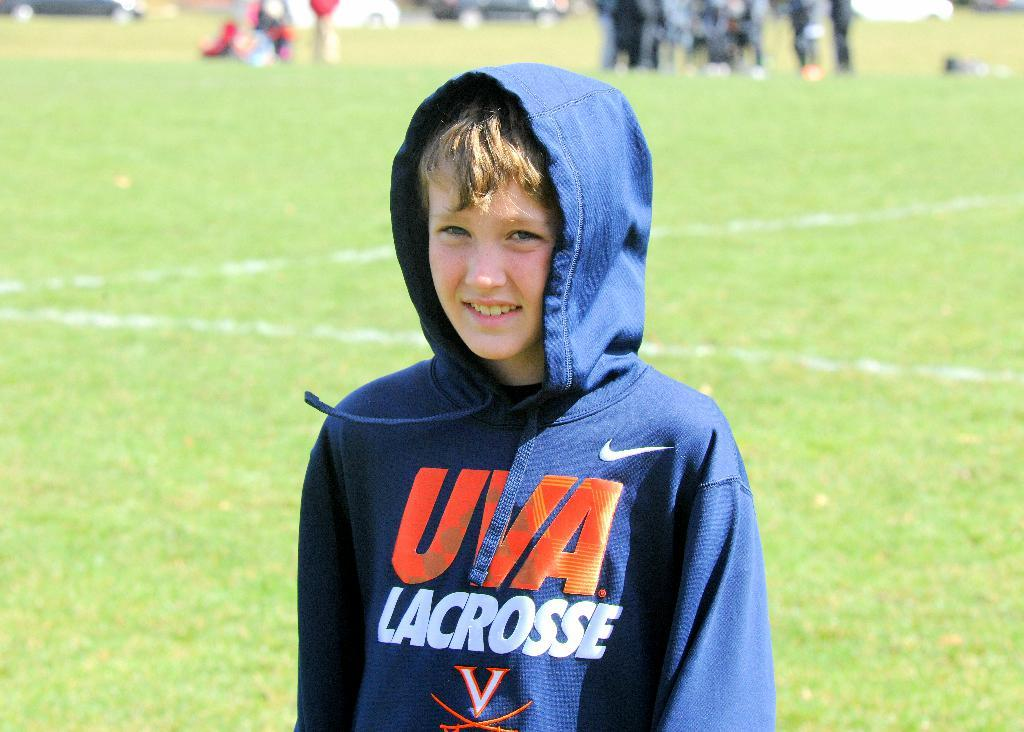What is the main subject of the image? The main subject of the image is a kid standing. What is the expression on the kid's face? The kid is smiling in the image. What type of surface is visible at the bottom of the image? There is grass at the bottom of the image. Can you describe the people in the background of the image? There are people standing in the background of the image, but they appear blurry. How many tomatoes can be seen growing on the bun in the image? There are no tomatoes or buns present in the image. Are there any horses visible in the background of the image? No, there are no horses visible in the image. 